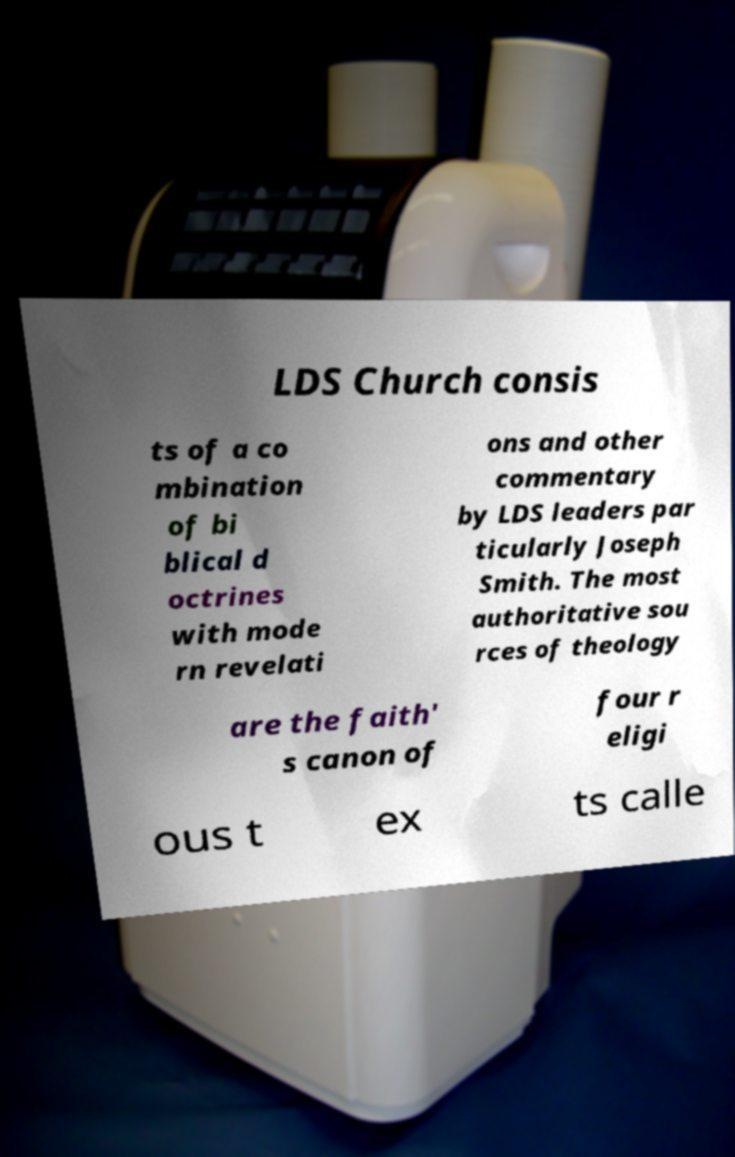I need the written content from this picture converted into text. Can you do that? LDS Church consis ts of a co mbination of bi blical d octrines with mode rn revelati ons and other commentary by LDS leaders par ticularly Joseph Smith. The most authoritative sou rces of theology are the faith' s canon of four r eligi ous t ex ts calle 